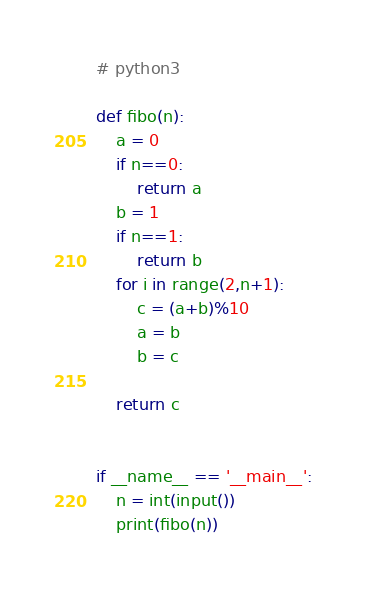Convert code to text. <code><loc_0><loc_0><loc_500><loc_500><_Python_># python3

def fibo(n):
    a = 0
    if n==0:
        return a
    b = 1
    if n==1:
        return b
    for i in range(2,n+1):
        c = (a+b)%10
        a = b
        b = c
            
    return c           
                

if __name__ == '__main__':
    n = int(input())  
    print(fibo(n))
     
</code> 